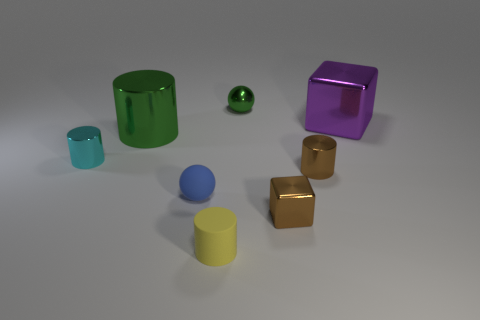Subtract all gray cylinders. Subtract all yellow blocks. How many cylinders are left? 4 Add 1 tiny matte cylinders. How many objects exist? 9 Subtract all blocks. How many objects are left? 6 Subtract 0 cyan cubes. How many objects are left? 8 Subtract all brown shiny cylinders. Subtract all tiny brown metallic blocks. How many objects are left? 6 Add 8 large purple objects. How many large purple objects are left? 9 Add 8 purple rubber blocks. How many purple rubber blocks exist? 8 